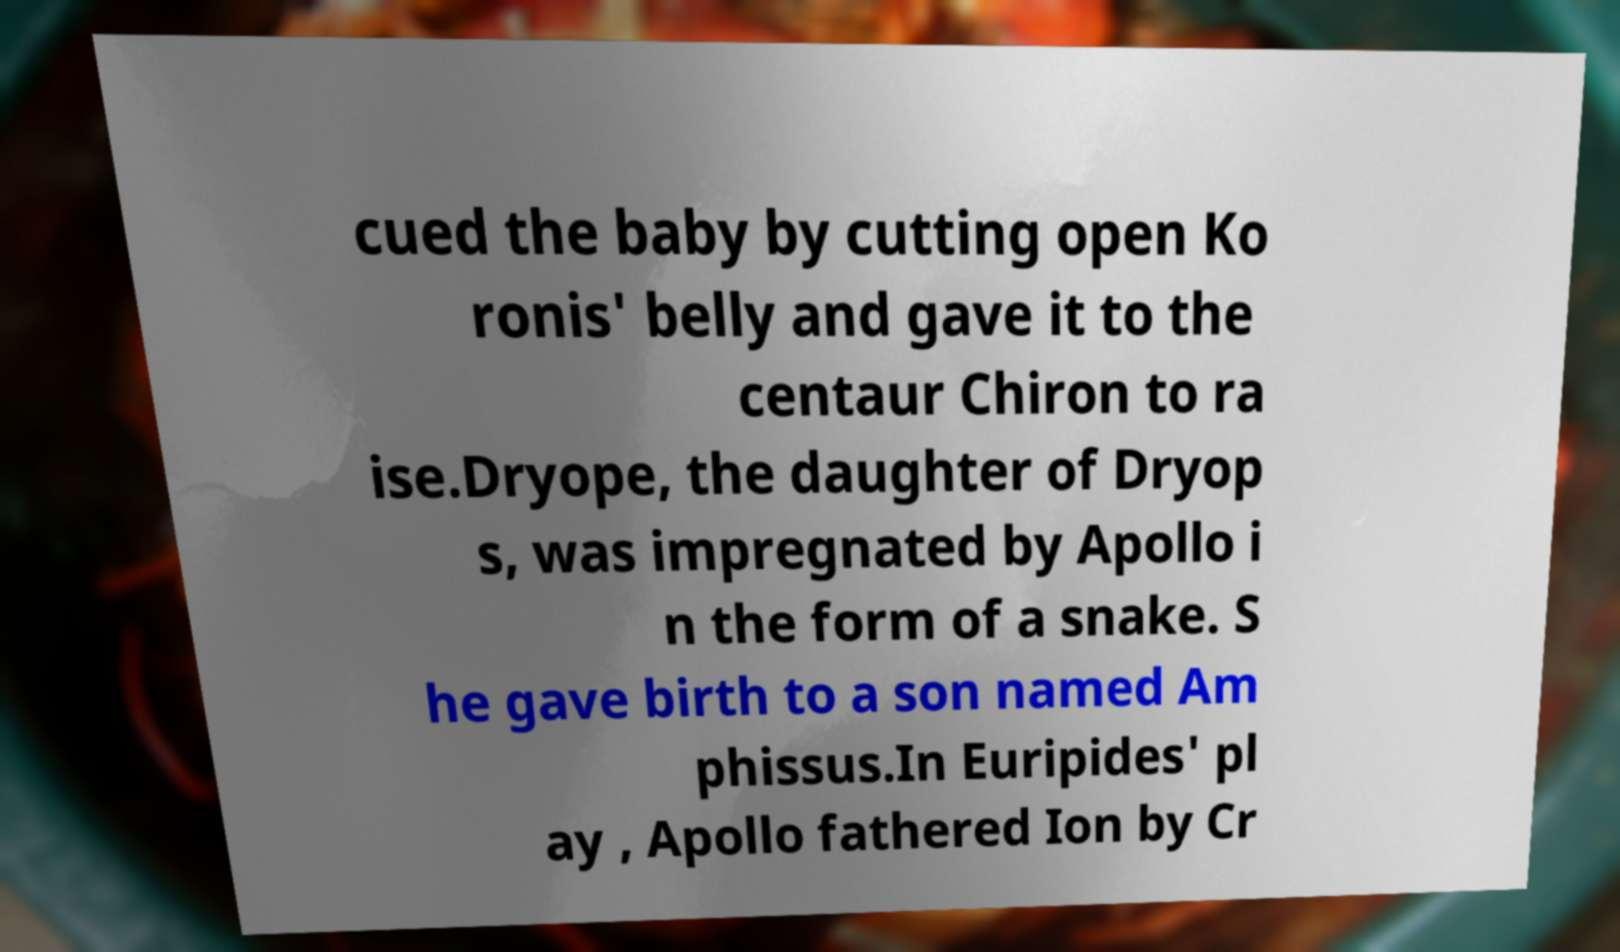There's text embedded in this image that I need extracted. Can you transcribe it verbatim? cued the baby by cutting open Ko ronis' belly and gave it to the centaur Chiron to ra ise.Dryope, the daughter of Dryop s, was impregnated by Apollo i n the form of a snake. S he gave birth to a son named Am phissus.In Euripides' pl ay , Apollo fathered Ion by Cr 